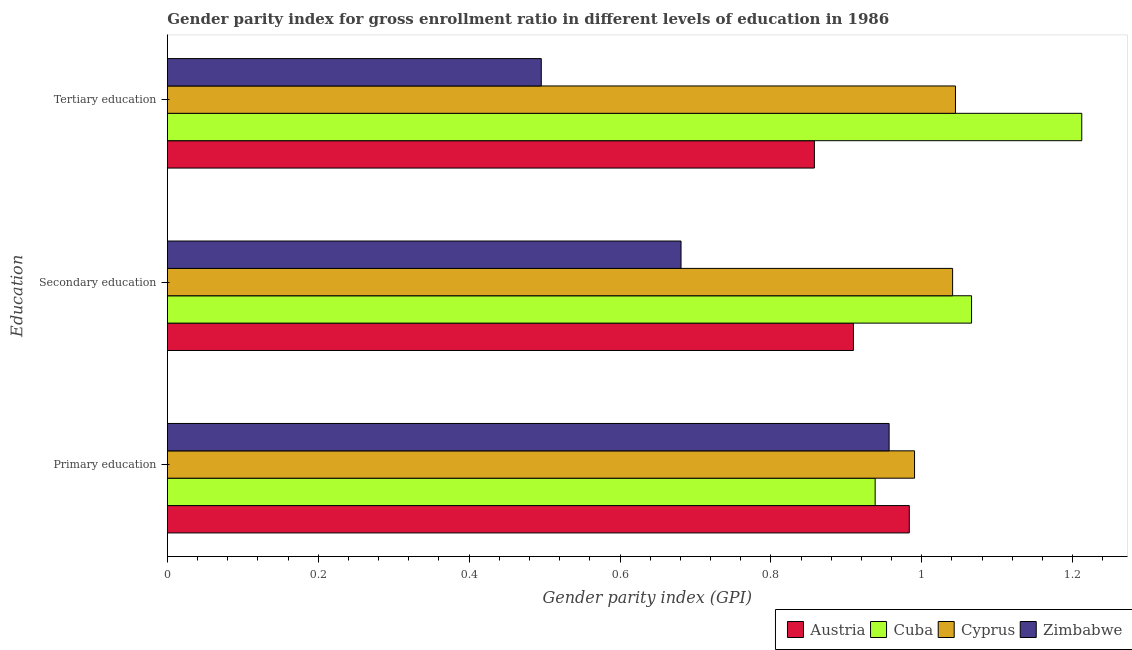How many bars are there on the 2nd tick from the top?
Provide a succinct answer. 4. How many bars are there on the 1st tick from the bottom?
Provide a succinct answer. 4. What is the label of the 2nd group of bars from the top?
Make the answer very short. Secondary education. What is the gender parity index in secondary education in Zimbabwe?
Ensure brevity in your answer.  0.68. Across all countries, what is the maximum gender parity index in primary education?
Your answer should be very brief. 0.99. Across all countries, what is the minimum gender parity index in secondary education?
Offer a terse response. 0.68. In which country was the gender parity index in secondary education maximum?
Give a very brief answer. Cuba. In which country was the gender parity index in tertiary education minimum?
Give a very brief answer. Zimbabwe. What is the total gender parity index in tertiary education in the graph?
Your response must be concise. 3.61. What is the difference between the gender parity index in primary education in Austria and that in Cyprus?
Give a very brief answer. -0.01. What is the difference between the gender parity index in primary education in Zimbabwe and the gender parity index in secondary education in Cyprus?
Offer a very short reply. -0.08. What is the average gender parity index in secondary education per country?
Ensure brevity in your answer.  0.92. What is the difference between the gender parity index in secondary education and gender parity index in tertiary education in Zimbabwe?
Give a very brief answer. 0.19. What is the ratio of the gender parity index in tertiary education in Zimbabwe to that in Cyprus?
Your answer should be very brief. 0.47. What is the difference between the highest and the second highest gender parity index in secondary education?
Your answer should be very brief. 0.03. What is the difference between the highest and the lowest gender parity index in primary education?
Provide a succinct answer. 0.05. In how many countries, is the gender parity index in primary education greater than the average gender parity index in primary education taken over all countries?
Ensure brevity in your answer.  2. What does the 1st bar from the top in Secondary education represents?
Offer a terse response. Zimbabwe. What does the 4th bar from the bottom in Primary education represents?
Provide a succinct answer. Zimbabwe. Is it the case that in every country, the sum of the gender parity index in primary education and gender parity index in secondary education is greater than the gender parity index in tertiary education?
Give a very brief answer. Yes. How many bars are there?
Offer a terse response. 12. Are all the bars in the graph horizontal?
Offer a terse response. Yes. Does the graph contain grids?
Offer a very short reply. No. How are the legend labels stacked?
Your answer should be compact. Horizontal. What is the title of the graph?
Provide a short and direct response. Gender parity index for gross enrollment ratio in different levels of education in 1986. What is the label or title of the X-axis?
Ensure brevity in your answer.  Gender parity index (GPI). What is the label or title of the Y-axis?
Ensure brevity in your answer.  Education. What is the Gender parity index (GPI) in Austria in Primary education?
Your answer should be compact. 0.98. What is the Gender parity index (GPI) in Cuba in Primary education?
Give a very brief answer. 0.94. What is the Gender parity index (GPI) of Cyprus in Primary education?
Your answer should be compact. 0.99. What is the Gender parity index (GPI) in Zimbabwe in Primary education?
Your answer should be compact. 0.96. What is the Gender parity index (GPI) in Austria in Secondary education?
Offer a terse response. 0.91. What is the Gender parity index (GPI) of Cuba in Secondary education?
Provide a succinct answer. 1.07. What is the Gender parity index (GPI) of Cyprus in Secondary education?
Offer a terse response. 1.04. What is the Gender parity index (GPI) in Zimbabwe in Secondary education?
Give a very brief answer. 0.68. What is the Gender parity index (GPI) of Austria in Tertiary education?
Offer a terse response. 0.86. What is the Gender parity index (GPI) of Cuba in Tertiary education?
Your response must be concise. 1.21. What is the Gender parity index (GPI) in Cyprus in Tertiary education?
Offer a very short reply. 1.04. What is the Gender parity index (GPI) of Zimbabwe in Tertiary education?
Make the answer very short. 0.5. Across all Education, what is the maximum Gender parity index (GPI) in Austria?
Your answer should be compact. 0.98. Across all Education, what is the maximum Gender parity index (GPI) in Cuba?
Give a very brief answer. 1.21. Across all Education, what is the maximum Gender parity index (GPI) of Cyprus?
Keep it short and to the point. 1.04. Across all Education, what is the maximum Gender parity index (GPI) in Zimbabwe?
Make the answer very short. 0.96. Across all Education, what is the minimum Gender parity index (GPI) of Austria?
Provide a short and direct response. 0.86. Across all Education, what is the minimum Gender parity index (GPI) of Cuba?
Your answer should be very brief. 0.94. Across all Education, what is the minimum Gender parity index (GPI) in Cyprus?
Provide a succinct answer. 0.99. Across all Education, what is the minimum Gender parity index (GPI) of Zimbabwe?
Your answer should be compact. 0.5. What is the total Gender parity index (GPI) in Austria in the graph?
Keep it short and to the point. 2.75. What is the total Gender parity index (GPI) of Cuba in the graph?
Ensure brevity in your answer.  3.22. What is the total Gender parity index (GPI) of Cyprus in the graph?
Your answer should be very brief. 3.08. What is the total Gender parity index (GPI) in Zimbabwe in the graph?
Give a very brief answer. 2.13. What is the difference between the Gender parity index (GPI) in Austria in Primary education and that in Secondary education?
Your response must be concise. 0.07. What is the difference between the Gender parity index (GPI) in Cuba in Primary education and that in Secondary education?
Keep it short and to the point. -0.13. What is the difference between the Gender parity index (GPI) of Cyprus in Primary education and that in Secondary education?
Offer a terse response. -0.05. What is the difference between the Gender parity index (GPI) in Zimbabwe in Primary education and that in Secondary education?
Give a very brief answer. 0.28. What is the difference between the Gender parity index (GPI) of Austria in Primary education and that in Tertiary education?
Offer a very short reply. 0.13. What is the difference between the Gender parity index (GPI) in Cuba in Primary education and that in Tertiary education?
Ensure brevity in your answer.  -0.27. What is the difference between the Gender parity index (GPI) of Cyprus in Primary education and that in Tertiary education?
Offer a very short reply. -0.05. What is the difference between the Gender parity index (GPI) in Zimbabwe in Primary education and that in Tertiary education?
Give a very brief answer. 0.46. What is the difference between the Gender parity index (GPI) of Austria in Secondary education and that in Tertiary education?
Offer a terse response. 0.05. What is the difference between the Gender parity index (GPI) in Cuba in Secondary education and that in Tertiary education?
Ensure brevity in your answer.  -0.15. What is the difference between the Gender parity index (GPI) of Cyprus in Secondary education and that in Tertiary education?
Offer a very short reply. -0. What is the difference between the Gender parity index (GPI) of Zimbabwe in Secondary education and that in Tertiary education?
Your answer should be very brief. 0.19. What is the difference between the Gender parity index (GPI) in Austria in Primary education and the Gender parity index (GPI) in Cuba in Secondary education?
Provide a short and direct response. -0.08. What is the difference between the Gender parity index (GPI) of Austria in Primary education and the Gender parity index (GPI) of Cyprus in Secondary education?
Make the answer very short. -0.06. What is the difference between the Gender parity index (GPI) in Austria in Primary education and the Gender parity index (GPI) in Zimbabwe in Secondary education?
Your answer should be very brief. 0.3. What is the difference between the Gender parity index (GPI) of Cuba in Primary education and the Gender parity index (GPI) of Cyprus in Secondary education?
Ensure brevity in your answer.  -0.1. What is the difference between the Gender parity index (GPI) in Cuba in Primary education and the Gender parity index (GPI) in Zimbabwe in Secondary education?
Offer a very short reply. 0.26. What is the difference between the Gender parity index (GPI) of Cyprus in Primary education and the Gender parity index (GPI) of Zimbabwe in Secondary education?
Give a very brief answer. 0.31. What is the difference between the Gender parity index (GPI) in Austria in Primary education and the Gender parity index (GPI) in Cuba in Tertiary education?
Make the answer very short. -0.23. What is the difference between the Gender parity index (GPI) of Austria in Primary education and the Gender parity index (GPI) of Cyprus in Tertiary education?
Make the answer very short. -0.06. What is the difference between the Gender parity index (GPI) of Austria in Primary education and the Gender parity index (GPI) of Zimbabwe in Tertiary education?
Provide a succinct answer. 0.49. What is the difference between the Gender parity index (GPI) of Cuba in Primary education and the Gender parity index (GPI) of Cyprus in Tertiary education?
Keep it short and to the point. -0.11. What is the difference between the Gender parity index (GPI) of Cuba in Primary education and the Gender parity index (GPI) of Zimbabwe in Tertiary education?
Provide a short and direct response. 0.44. What is the difference between the Gender parity index (GPI) in Cyprus in Primary education and the Gender parity index (GPI) in Zimbabwe in Tertiary education?
Your answer should be very brief. 0.49. What is the difference between the Gender parity index (GPI) of Austria in Secondary education and the Gender parity index (GPI) of Cuba in Tertiary education?
Provide a short and direct response. -0.3. What is the difference between the Gender parity index (GPI) of Austria in Secondary education and the Gender parity index (GPI) of Cyprus in Tertiary education?
Ensure brevity in your answer.  -0.14. What is the difference between the Gender parity index (GPI) in Austria in Secondary education and the Gender parity index (GPI) in Zimbabwe in Tertiary education?
Your response must be concise. 0.41. What is the difference between the Gender parity index (GPI) in Cuba in Secondary education and the Gender parity index (GPI) in Cyprus in Tertiary education?
Ensure brevity in your answer.  0.02. What is the difference between the Gender parity index (GPI) of Cuba in Secondary education and the Gender parity index (GPI) of Zimbabwe in Tertiary education?
Make the answer very short. 0.57. What is the difference between the Gender parity index (GPI) in Cyprus in Secondary education and the Gender parity index (GPI) in Zimbabwe in Tertiary education?
Give a very brief answer. 0.55. What is the average Gender parity index (GPI) in Austria per Education?
Provide a succinct answer. 0.92. What is the average Gender parity index (GPI) in Cuba per Education?
Offer a terse response. 1.07. What is the average Gender parity index (GPI) in Cyprus per Education?
Your answer should be compact. 1.03. What is the average Gender parity index (GPI) in Zimbabwe per Education?
Your answer should be compact. 0.71. What is the difference between the Gender parity index (GPI) of Austria and Gender parity index (GPI) of Cuba in Primary education?
Your answer should be very brief. 0.05. What is the difference between the Gender parity index (GPI) in Austria and Gender parity index (GPI) in Cyprus in Primary education?
Your answer should be very brief. -0.01. What is the difference between the Gender parity index (GPI) in Austria and Gender parity index (GPI) in Zimbabwe in Primary education?
Provide a succinct answer. 0.03. What is the difference between the Gender parity index (GPI) in Cuba and Gender parity index (GPI) in Cyprus in Primary education?
Offer a terse response. -0.05. What is the difference between the Gender parity index (GPI) in Cuba and Gender parity index (GPI) in Zimbabwe in Primary education?
Keep it short and to the point. -0.02. What is the difference between the Gender parity index (GPI) in Cyprus and Gender parity index (GPI) in Zimbabwe in Primary education?
Provide a succinct answer. 0.03. What is the difference between the Gender parity index (GPI) of Austria and Gender parity index (GPI) of Cuba in Secondary education?
Your response must be concise. -0.16. What is the difference between the Gender parity index (GPI) in Austria and Gender parity index (GPI) in Cyprus in Secondary education?
Your answer should be compact. -0.13. What is the difference between the Gender parity index (GPI) in Austria and Gender parity index (GPI) in Zimbabwe in Secondary education?
Offer a terse response. 0.23. What is the difference between the Gender parity index (GPI) of Cuba and Gender parity index (GPI) of Cyprus in Secondary education?
Offer a terse response. 0.03. What is the difference between the Gender parity index (GPI) in Cuba and Gender parity index (GPI) in Zimbabwe in Secondary education?
Make the answer very short. 0.39. What is the difference between the Gender parity index (GPI) of Cyprus and Gender parity index (GPI) of Zimbabwe in Secondary education?
Offer a terse response. 0.36. What is the difference between the Gender parity index (GPI) in Austria and Gender parity index (GPI) in Cuba in Tertiary education?
Provide a short and direct response. -0.35. What is the difference between the Gender parity index (GPI) in Austria and Gender parity index (GPI) in Cyprus in Tertiary education?
Your answer should be very brief. -0.19. What is the difference between the Gender parity index (GPI) in Austria and Gender parity index (GPI) in Zimbabwe in Tertiary education?
Your answer should be compact. 0.36. What is the difference between the Gender parity index (GPI) in Cuba and Gender parity index (GPI) in Cyprus in Tertiary education?
Give a very brief answer. 0.17. What is the difference between the Gender parity index (GPI) of Cuba and Gender parity index (GPI) of Zimbabwe in Tertiary education?
Your answer should be very brief. 0.72. What is the difference between the Gender parity index (GPI) in Cyprus and Gender parity index (GPI) in Zimbabwe in Tertiary education?
Offer a terse response. 0.55. What is the ratio of the Gender parity index (GPI) in Austria in Primary education to that in Secondary education?
Make the answer very short. 1.08. What is the ratio of the Gender parity index (GPI) of Cuba in Primary education to that in Secondary education?
Your answer should be very brief. 0.88. What is the ratio of the Gender parity index (GPI) in Cyprus in Primary education to that in Secondary education?
Your answer should be compact. 0.95. What is the ratio of the Gender parity index (GPI) of Zimbabwe in Primary education to that in Secondary education?
Provide a succinct answer. 1.41. What is the ratio of the Gender parity index (GPI) in Austria in Primary education to that in Tertiary education?
Provide a short and direct response. 1.15. What is the ratio of the Gender parity index (GPI) of Cuba in Primary education to that in Tertiary education?
Your answer should be very brief. 0.77. What is the ratio of the Gender parity index (GPI) in Cyprus in Primary education to that in Tertiary education?
Make the answer very short. 0.95. What is the ratio of the Gender parity index (GPI) in Zimbabwe in Primary education to that in Tertiary education?
Your answer should be very brief. 1.93. What is the ratio of the Gender parity index (GPI) of Austria in Secondary education to that in Tertiary education?
Provide a succinct answer. 1.06. What is the ratio of the Gender parity index (GPI) of Cuba in Secondary education to that in Tertiary education?
Your answer should be very brief. 0.88. What is the ratio of the Gender parity index (GPI) in Cyprus in Secondary education to that in Tertiary education?
Offer a very short reply. 1. What is the ratio of the Gender parity index (GPI) of Zimbabwe in Secondary education to that in Tertiary education?
Offer a very short reply. 1.37. What is the difference between the highest and the second highest Gender parity index (GPI) of Austria?
Make the answer very short. 0.07. What is the difference between the highest and the second highest Gender parity index (GPI) of Cuba?
Your answer should be very brief. 0.15. What is the difference between the highest and the second highest Gender parity index (GPI) in Cyprus?
Keep it short and to the point. 0. What is the difference between the highest and the second highest Gender parity index (GPI) in Zimbabwe?
Keep it short and to the point. 0.28. What is the difference between the highest and the lowest Gender parity index (GPI) of Austria?
Your answer should be very brief. 0.13. What is the difference between the highest and the lowest Gender parity index (GPI) in Cuba?
Provide a succinct answer. 0.27. What is the difference between the highest and the lowest Gender parity index (GPI) in Cyprus?
Your answer should be very brief. 0.05. What is the difference between the highest and the lowest Gender parity index (GPI) of Zimbabwe?
Make the answer very short. 0.46. 